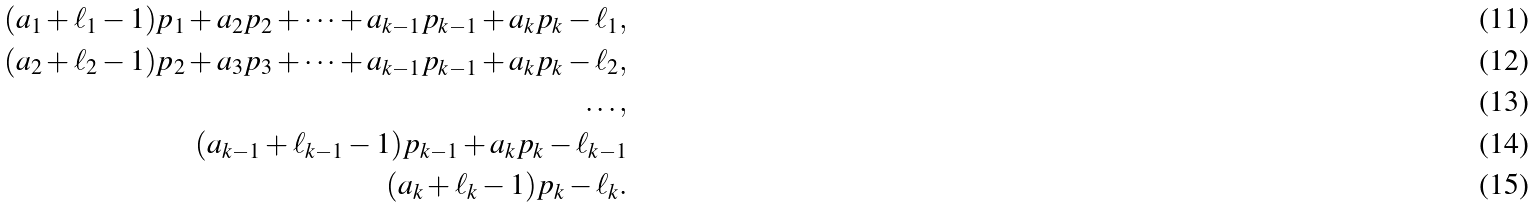<formula> <loc_0><loc_0><loc_500><loc_500>( a _ { 1 } + \ell _ { 1 } - 1 ) p _ { 1 } + a _ { 2 } p _ { 2 } + \dots + a _ { k - 1 } p _ { k - 1 } + a _ { k } p _ { k } - \ell _ { 1 } , \\ ( a _ { 2 } + \ell _ { 2 } - 1 ) p _ { 2 } + a _ { 3 } p _ { 3 } + \dots + a _ { k - 1 } p _ { k - 1 } + a _ { k } p _ { k } - \ell _ { 2 } , \\ \dots , \\ ( a _ { k - 1 } + \ell _ { k - 1 } - 1 ) p _ { k - 1 } + a _ { k } p _ { k } - \ell _ { k - 1 } \\ ( a _ { k } + \ell _ { k } - 1 ) p _ { k } - \ell _ { k } .</formula> 